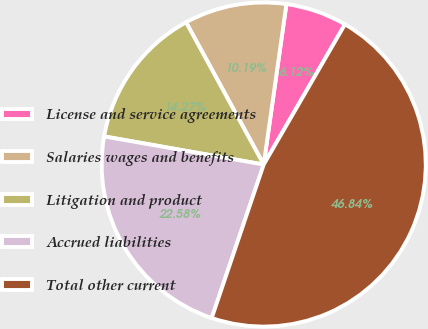Convert chart to OTSL. <chart><loc_0><loc_0><loc_500><loc_500><pie_chart><fcel>License and service agreements<fcel>Salaries wages and benefits<fcel>Litigation and product<fcel>Accrued liabilities<fcel>Total other current<nl><fcel>6.12%<fcel>10.19%<fcel>14.27%<fcel>22.58%<fcel>46.84%<nl></chart> 